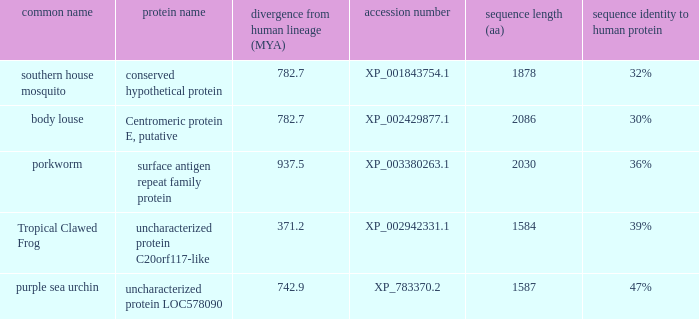What is the sequence length (aa) of the protein with the common name Purple Sea Urchin and a divergence from human lineage less than 742.9? None. 